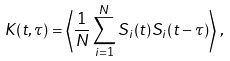Convert formula to latex. <formula><loc_0><loc_0><loc_500><loc_500>K ( t , \tau ) = \left \langle \frac { 1 } { N } \sum _ { i = 1 } ^ { N } S _ { i } ( t ) S _ { i } ( t - \tau ) \right \rangle \, ,</formula> 